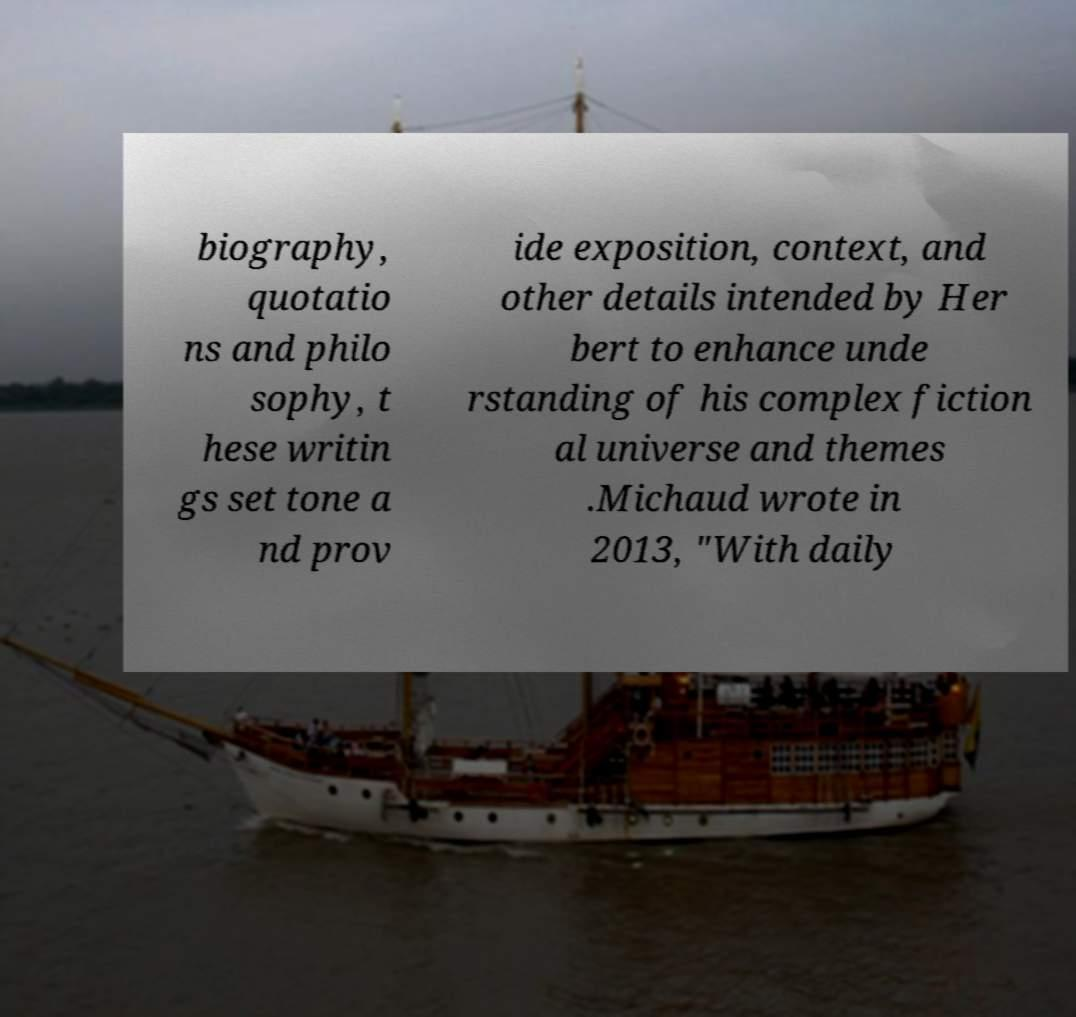I need the written content from this picture converted into text. Can you do that? biography, quotatio ns and philo sophy, t hese writin gs set tone a nd prov ide exposition, context, and other details intended by Her bert to enhance unde rstanding of his complex fiction al universe and themes .Michaud wrote in 2013, "With daily 